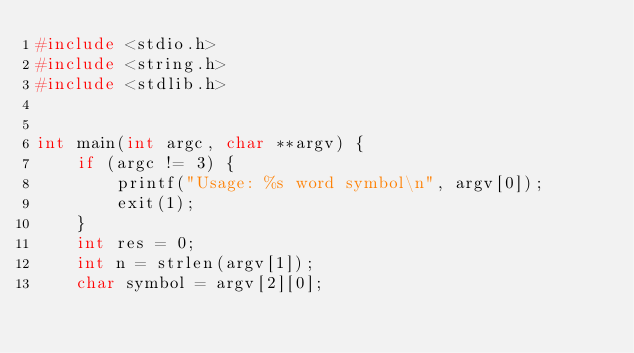Convert code to text. <code><loc_0><loc_0><loc_500><loc_500><_C_>#include <stdio.h>
#include <string.h>
#include <stdlib.h>


int main(int argc, char **argv) {
	if (argc != 3) {
		printf("Usage: %s word symbol\n", argv[0]);
		exit(1);
	}
	int res = 0;
	int n = strlen(argv[1]);
	char symbol = argv[2][0];
	</code> 